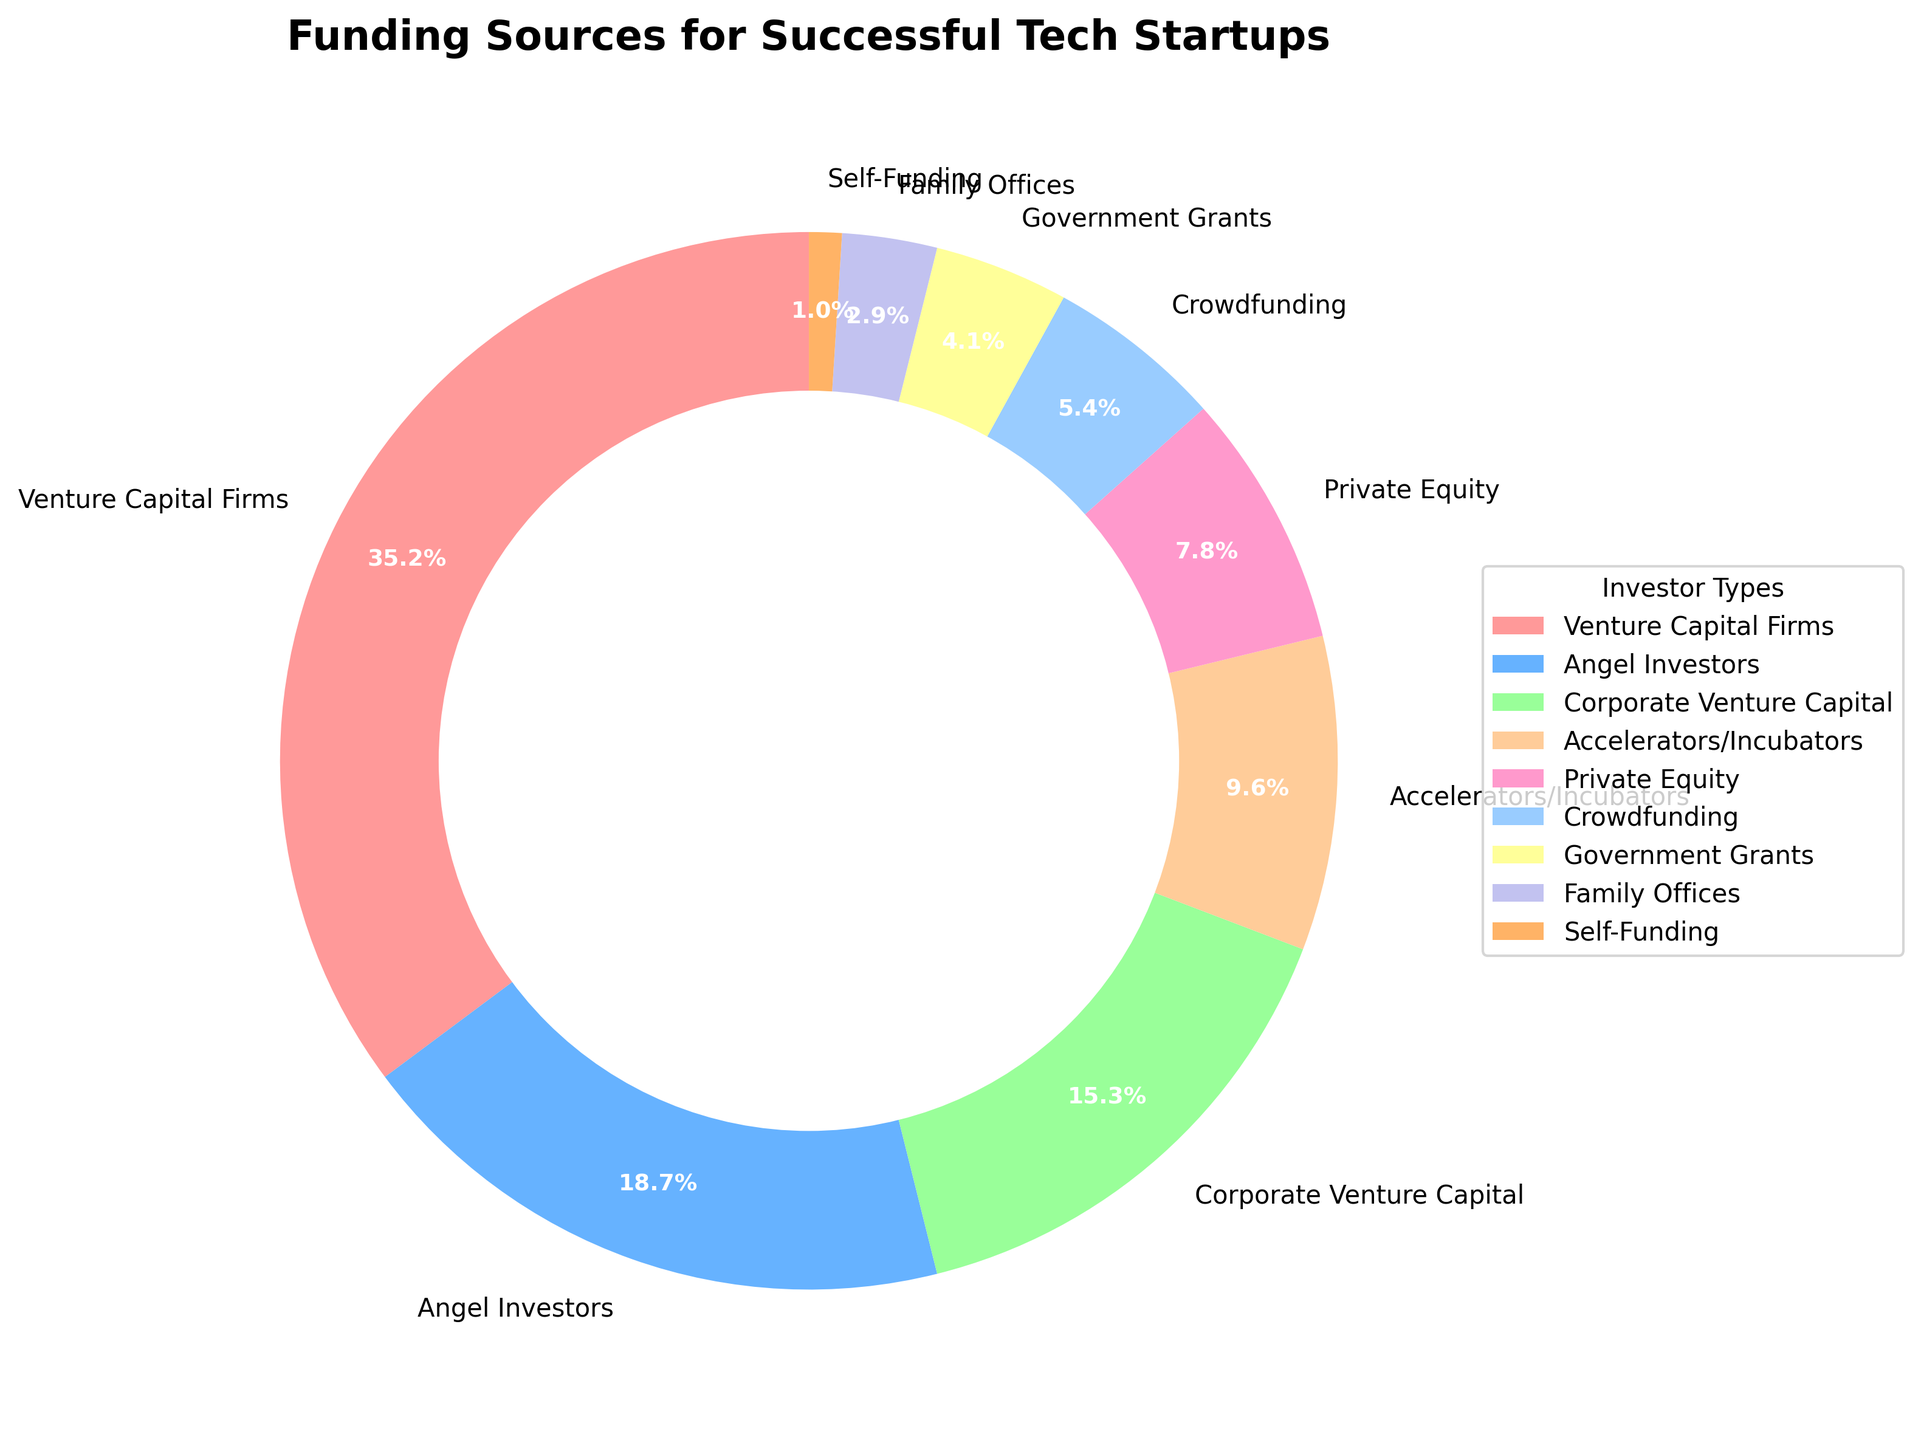What is the most significant funding source for successful tech startups? The pie chart shows that the sector with the largest percentage is "Venture Capital Firms" at 35.2%.
Answer: Venture Capital Firms Which funding source has a slightly greater representation: Crowdfunding or Government Grants? Crowdfunding accounts for 5.4% of the funding, while Government Grants account for 4.1%. Therefore, Crowdfunding has a slightly greater representation.
Answer: Crowdfunding What is the combined percentage of funding coming from Corporate Venture Capital and Private Equity? According to the pie chart, Corporate Venture Capital accounts for 15.3% and Private Equity accounts for 7.8%. Their combined percentage is 15.3% + 7.8% = 23.1%.
Answer: 23.1% Which investor type has less representation: Self-Funding or Family Offices? The pie chart shows that Self-Funding has 1.0% and Family Offices have 2.9%. Therefore, Self-Funding has less representation.
Answer: Self-Funding What is the difference in percentage points between the contributions of Angel Investors and Accelerators/Incubators? Angel Investors contribute 18.7%, while Accelerators/Incubators contribute 9.6%. The difference is 18.7% - 9.6% = 9.1%.
Answer: 9.1 How much more do Venture Capital Firms contribute compared to Private Equity? Venture Capital Firms contribute 35.2%, and Private Equity contributes 7.8%. The difference is 35.2% - 7.8% = 27.4%.
Answer: 27.4 What is the total percentage of funding represented by non-crowdsourced sources? The non-crowdsourced sources include all categories except Crowdfunding. Summing their percentages: 35.2 + 18.7 + 15.3 + 9.6 + 7.8 + 4.1 + 2.9 + 1.0 = 94.6%.
Answer: 94.6 Which investor type is associated with the color red? The pie chart indicates that "Venture Capital Firms" is associated with the color red and represents 35.2% of the funding sources.
Answer: Venture Capital Firms 